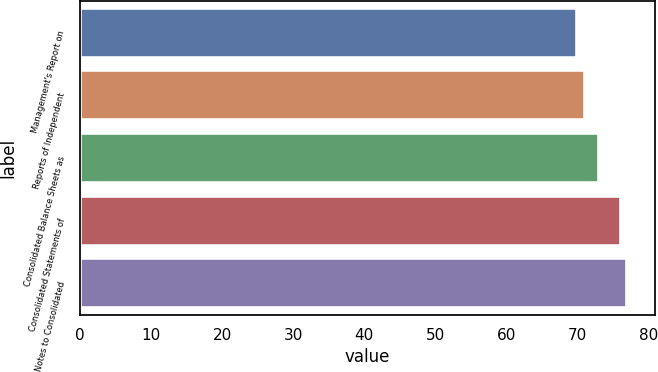Convert chart. <chart><loc_0><loc_0><loc_500><loc_500><bar_chart><fcel>Management's Report on<fcel>Reports of Independent<fcel>Consolidated Balance Sheets as<fcel>Consolidated Statements of<fcel>Notes to Consolidated<nl><fcel>70<fcel>71<fcel>73<fcel>76.1<fcel>77<nl></chart> 